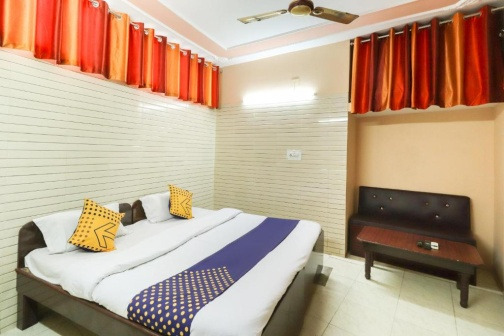Can you tell me more about the choice of colors in this room's decor? Certainly! The room uses a palette that combines neutral tones with bold colors to create a balance that is visually pleasing. The white and beige walls provide a calm and neutral backdrop, which makes the vibrant hues of the blue bedspread and red curtains stand out, adding character and vitality to the space. The yellow pillows introduce a contrasting splash of cheerfulness. These color choices contribute both to the aesthetic of the room and influence its mood, making it both inviting and energetic. 